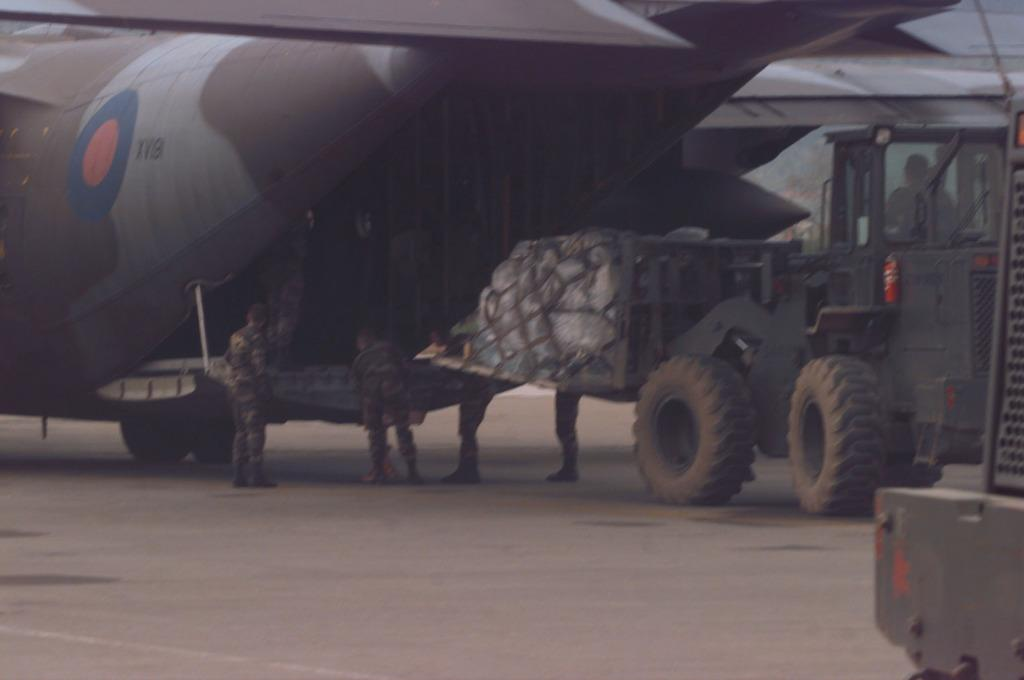What can be seen running along the ground in the image? There is a path in the image. What is located on the path in the image? There is an airplane and a vehicle on the path. Who is present in the image? There are men wearing army uniforms in the image. What type of smile can be seen on the earth in the image? There is no earth or smile present in the image. How many feet are visible in the image? There is no reference to feet in the image. 